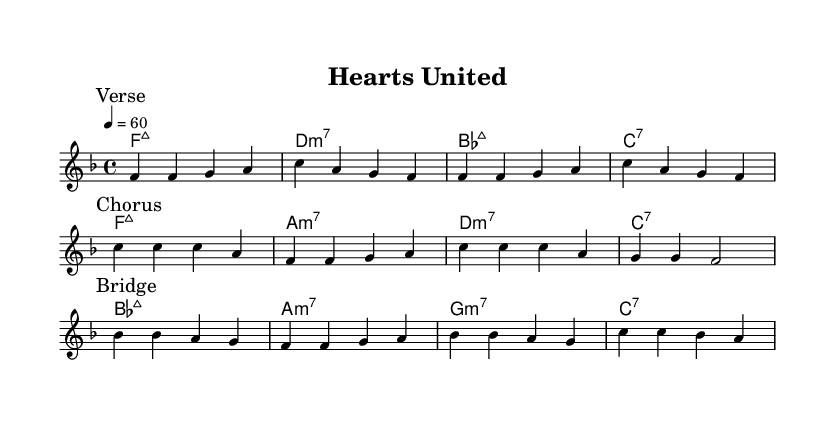What is the key signature of this music? The key signature is F major, which has one flat (B flat).
Answer: F major What is the time signature of this music? The time signature is 4/4, meaning there are four beats in a measure.
Answer: 4/4 What is the tempo marking for this piece? The tempo marking indicates a speed of 60 beats per minute.
Answer: 60 Which chord is used at the beginning of the chorus? The first chord in the chorus section is C major.
Answer: C major How many measures are there in the bridge? The bridge consists of four measures as indicated by the bars in the music.
Answer: 4 What type of seventh chord is used at the end of the harmonies? The final chord listed in the harmonies is a C dominant seventh chord.
Answer: C7 Which musical section follows the verse? The section that follows the verse is the chorus.
Answer: Chorus 